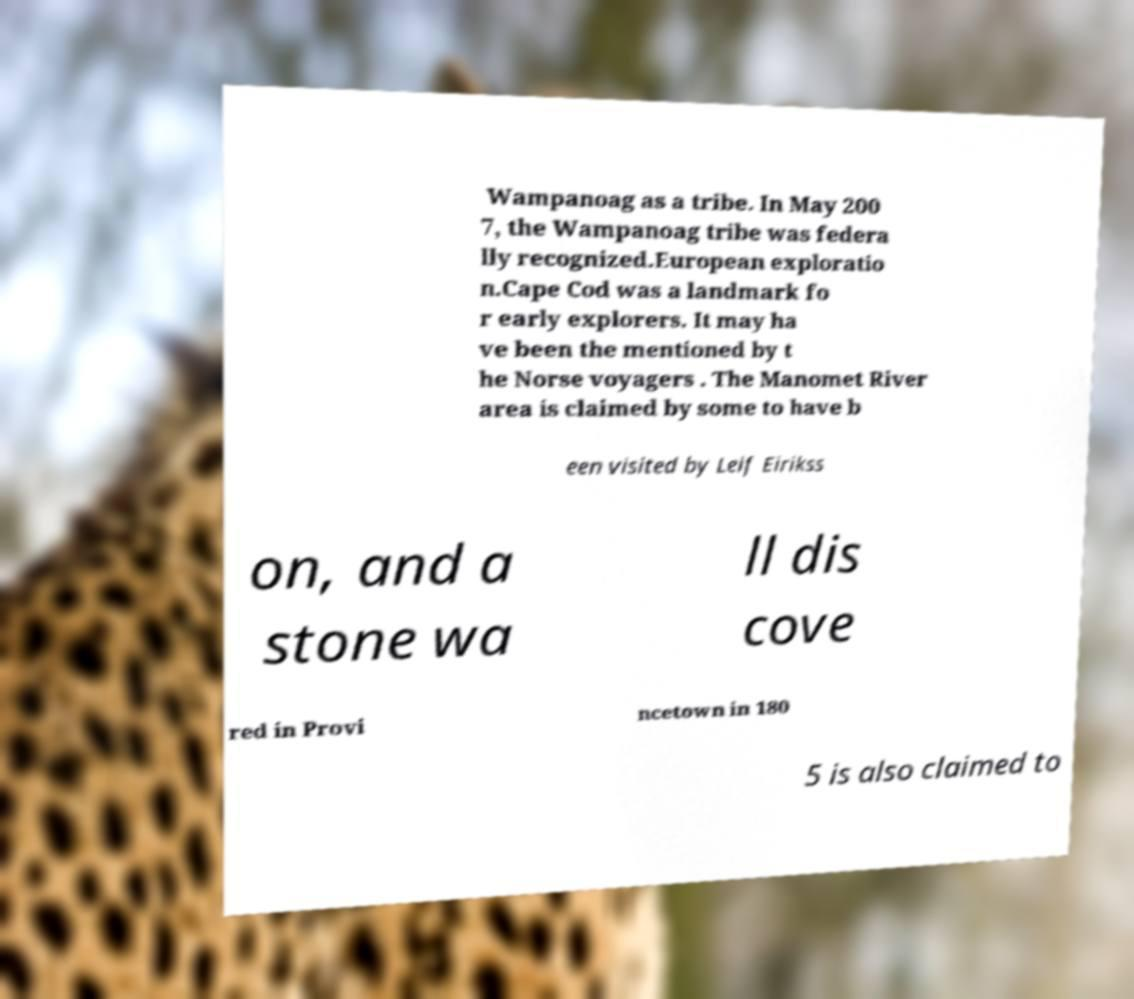I need the written content from this picture converted into text. Can you do that? Wampanoag as a tribe. In May 200 7, the Wampanoag tribe was federa lly recognized.European exploratio n.Cape Cod was a landmark fo r early explorers. It may ha ve been the mentioned by t he Norse voyagers . The Manomet River area is claimed by some to have b een visited by Leif Eirikss on, and a stone wa ll dis cove red in Provi ncetown in 180 5 is also claimed to 